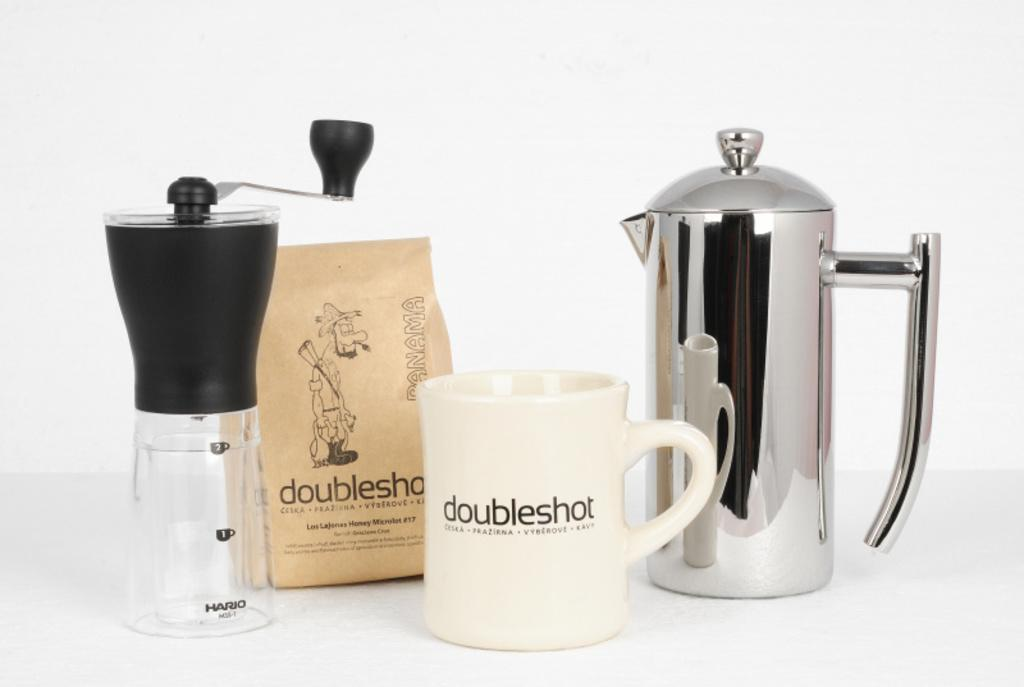<image>
Share a concise interpretation of the image provided. A white mug with the word doubleshot next to a coffee grinder. 